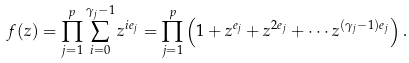Convert formula to latex. <formula><loc_0><loc_0><loc_500><loc_500>f ( z ) = \prod _ { j = 1 } ^ { p } \sum _ { i = 0 } ^ { \gamma _ { j } - 1 } z ^ { i e _ { j } } = \prod _ { j = 1 } ^ { p } \left ( 1 + z ^ { e _ { j } } + z ^ { 2 e _ { j } } + \cdots z ^ { ( \gamma _ { j } - 1 ) e _ { j } } \right ) .</formula> 